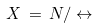Convert formula to latex. <formula><loc_0><loc_0><loc_500><loc_500>X \, = \, N / \leftrightarrow</formula> 